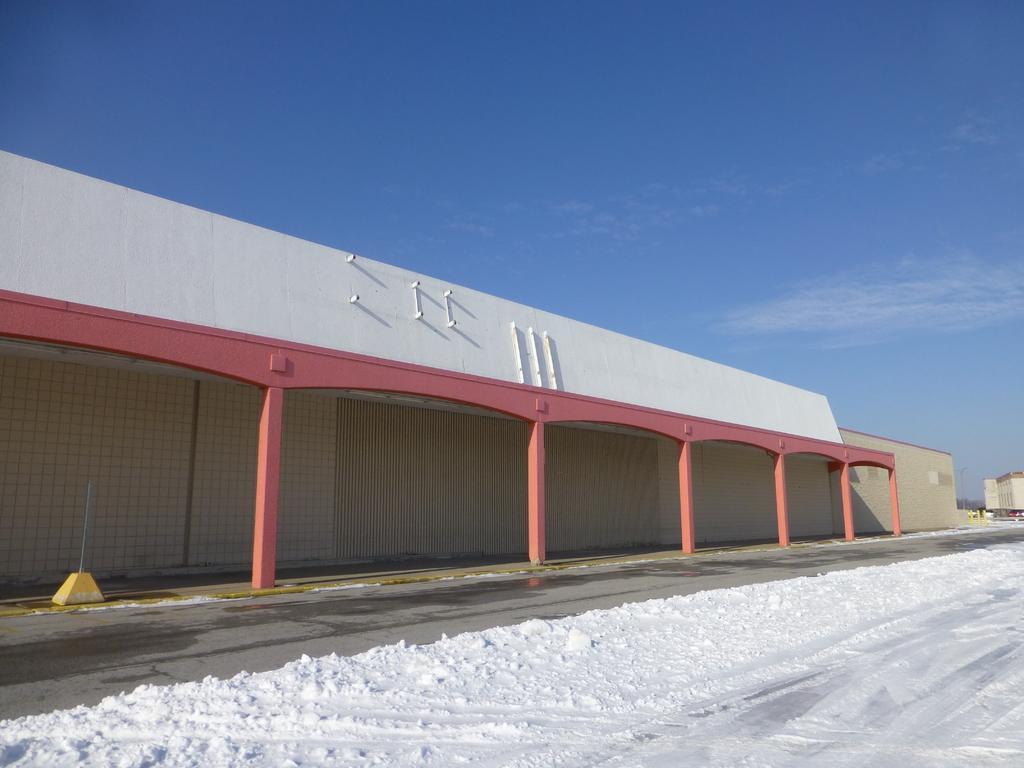Could you give a brief overview of what you see in this image? In this picture there is a building which is in white and pink color and there is snow beside it and there are few vehicles and some other buildings in the right corner and the sky is in blue color. 